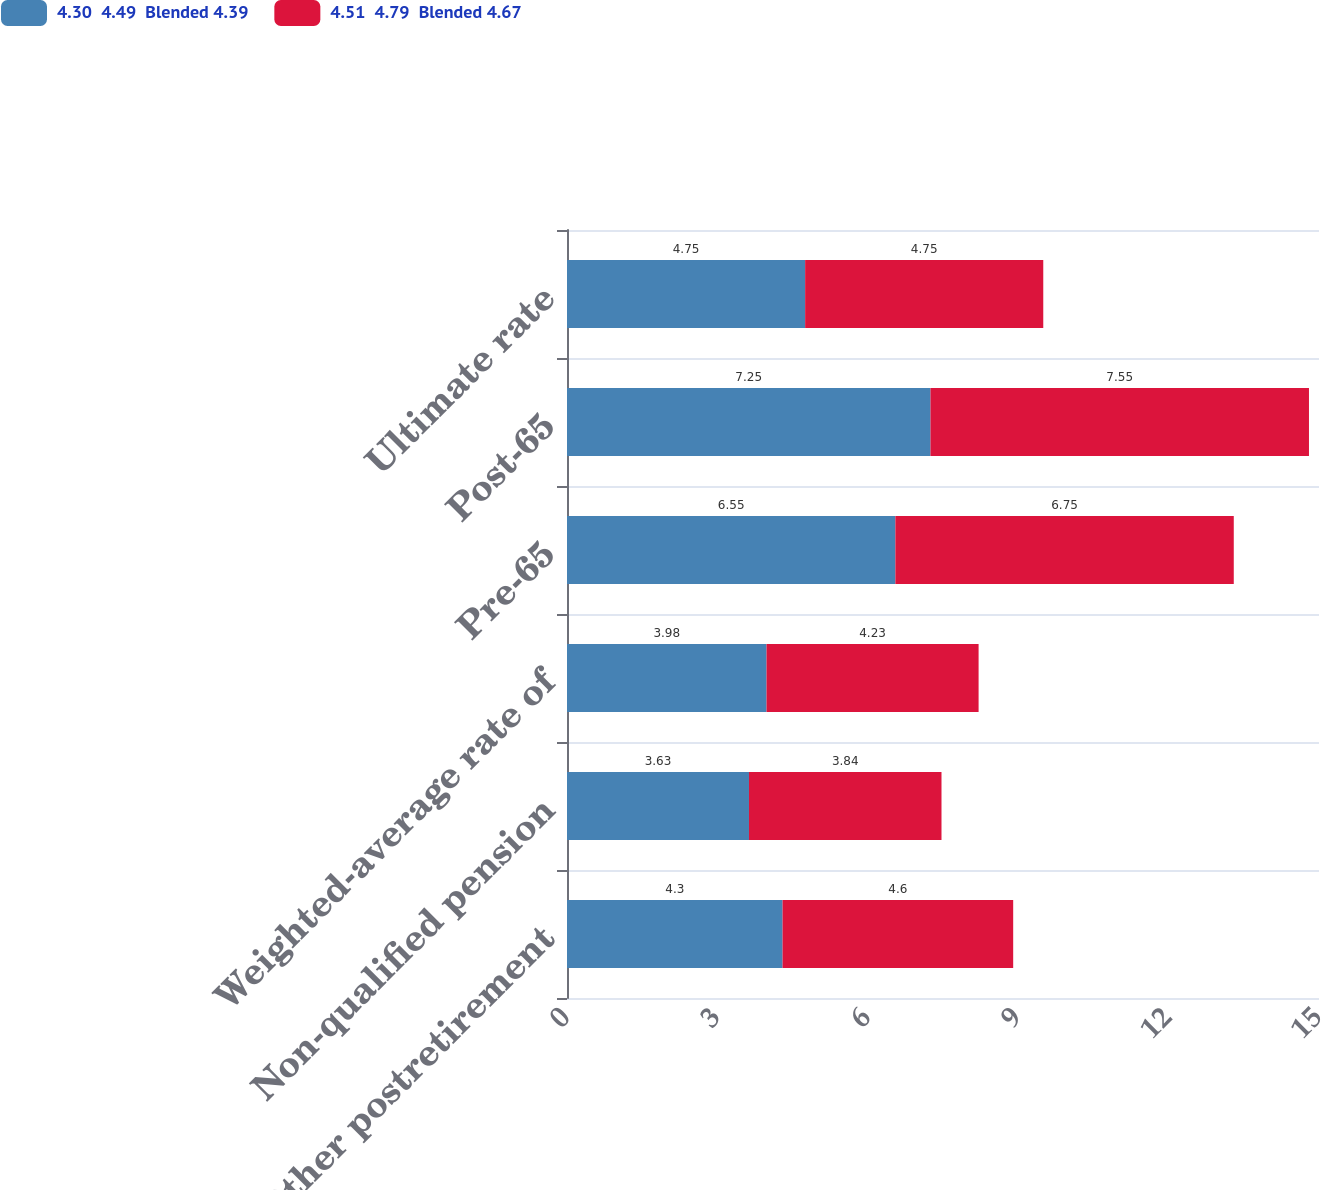<chart> <loc_0><loc_0><loc_500><loc_500><stacked_bar_chart><ecel><fcel>Other postretirement<fcel>Non-qualified pension<fcel>Weighted-average rate of<fcel>Pre-65<fcel>Post-65<fcel>Ultimate rate<nl><fcel>4.30  4.49  Blended 4.39<fcel>4.3<fcel>3.63<fcel>3.98<fcel>6.55<fcel>7.25<fcel>4.75<nl><fcel>4.51  4.79  Blended 4.67<fcel>4.6<fcel>3.84<fcel>4.23<fcel>6.75<fcel>7.55<fcel>4.75<nl></chart> 